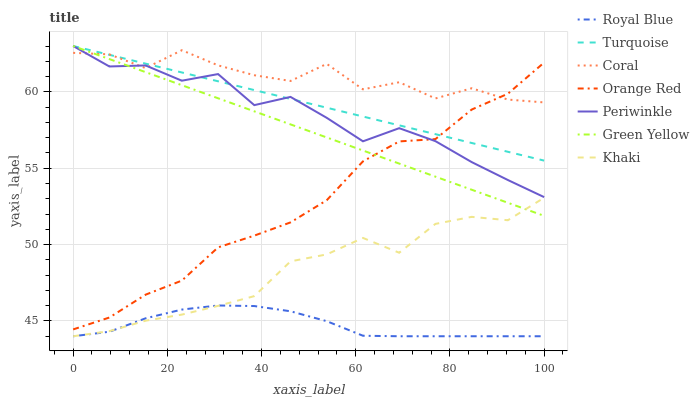Does Royal Blue have the minimum area under the curve?
Answer yes or no. Yes. Does Coral have the maximum area under the curve?
Answer yes or no. Yes. Does Khaki have the minimum area under the curve?
Answer yes or no. No. Does Khaki have the maximum area under the curve?
Answer yes or no. No. Is Green Yellow the smoothest?
Answer yes or no. Yes. Is Coral the roughest?
Answer yes or no. Yes. Is Khaki the smoothest?
Answer yes or no. No. Is Khaki the roughest?
Answer yes or no. No. Does Khaki have the lowest value?
Answer yes or no. Yes. Does Coral have the lowest value?
Answer yes or no. No. Does Green Yellow have the highest value?
Answer yes or no. Yes. Does Khaki have the highest value?
Answer yes or no. No. Is Khaki less than Orange Red?
Answer yes or no. Yes. Is Green Yellow greater than Royal Blue?
Answer yes or no. Yes. Does Coral intersect Orange Red?
Answer yes or no. Yes. Is Coral less than Orange Red?
Answer yes or no. No. Is Coral greater than Orange Red?
Answer yes or no. No. Does Khaki intersect Orange Red?
Answer yes or no. No. 